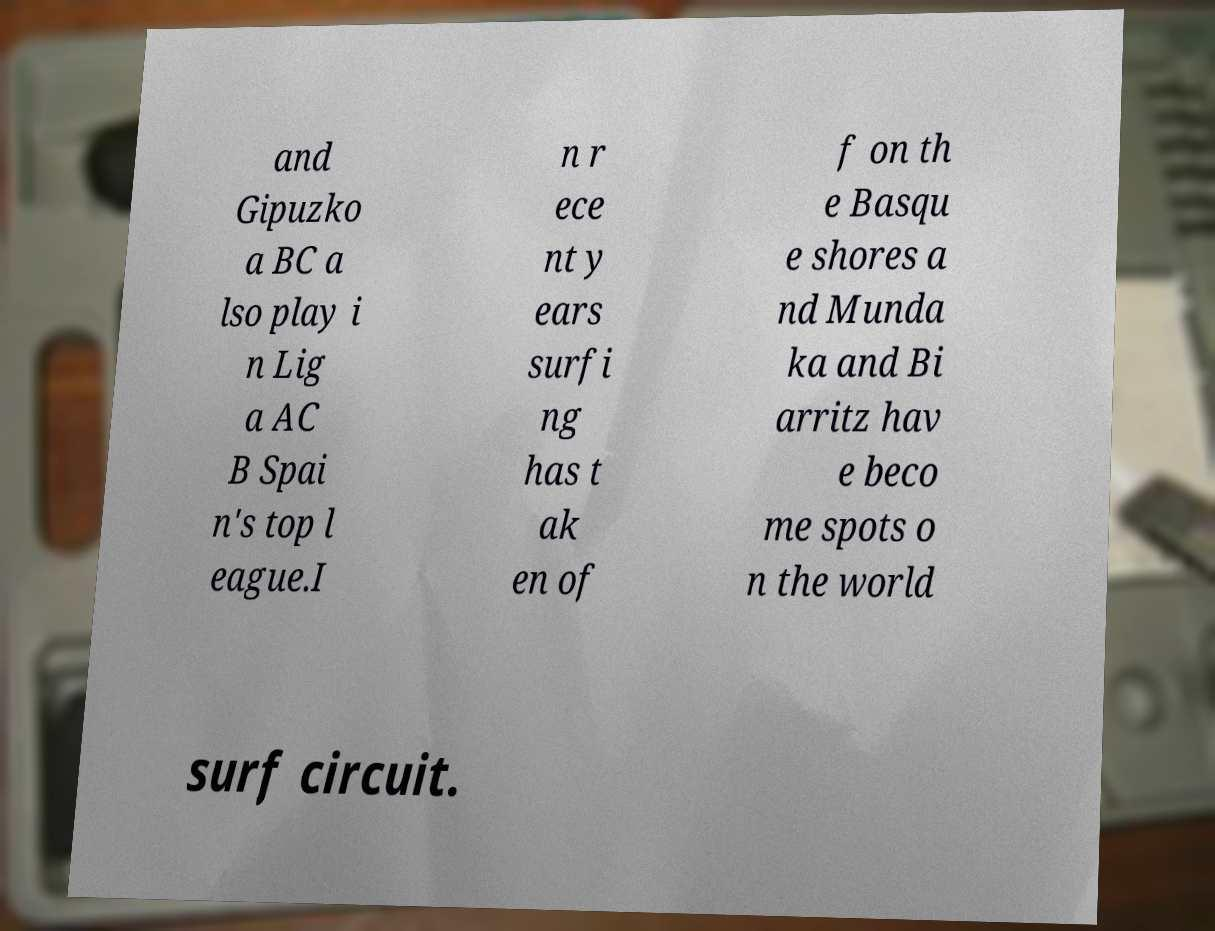Could you assist in decoding the text presented in this image and type it out clearly? and Gipuzko a BC a lso play i n Lig a AC B Spai n's top l eague.I n r ece nt y ears surfi ng has t ak en of f on th e Basqu e shores a nd Munda ka and Bi arritz hav e beco me spots o n the world surf circuit. 